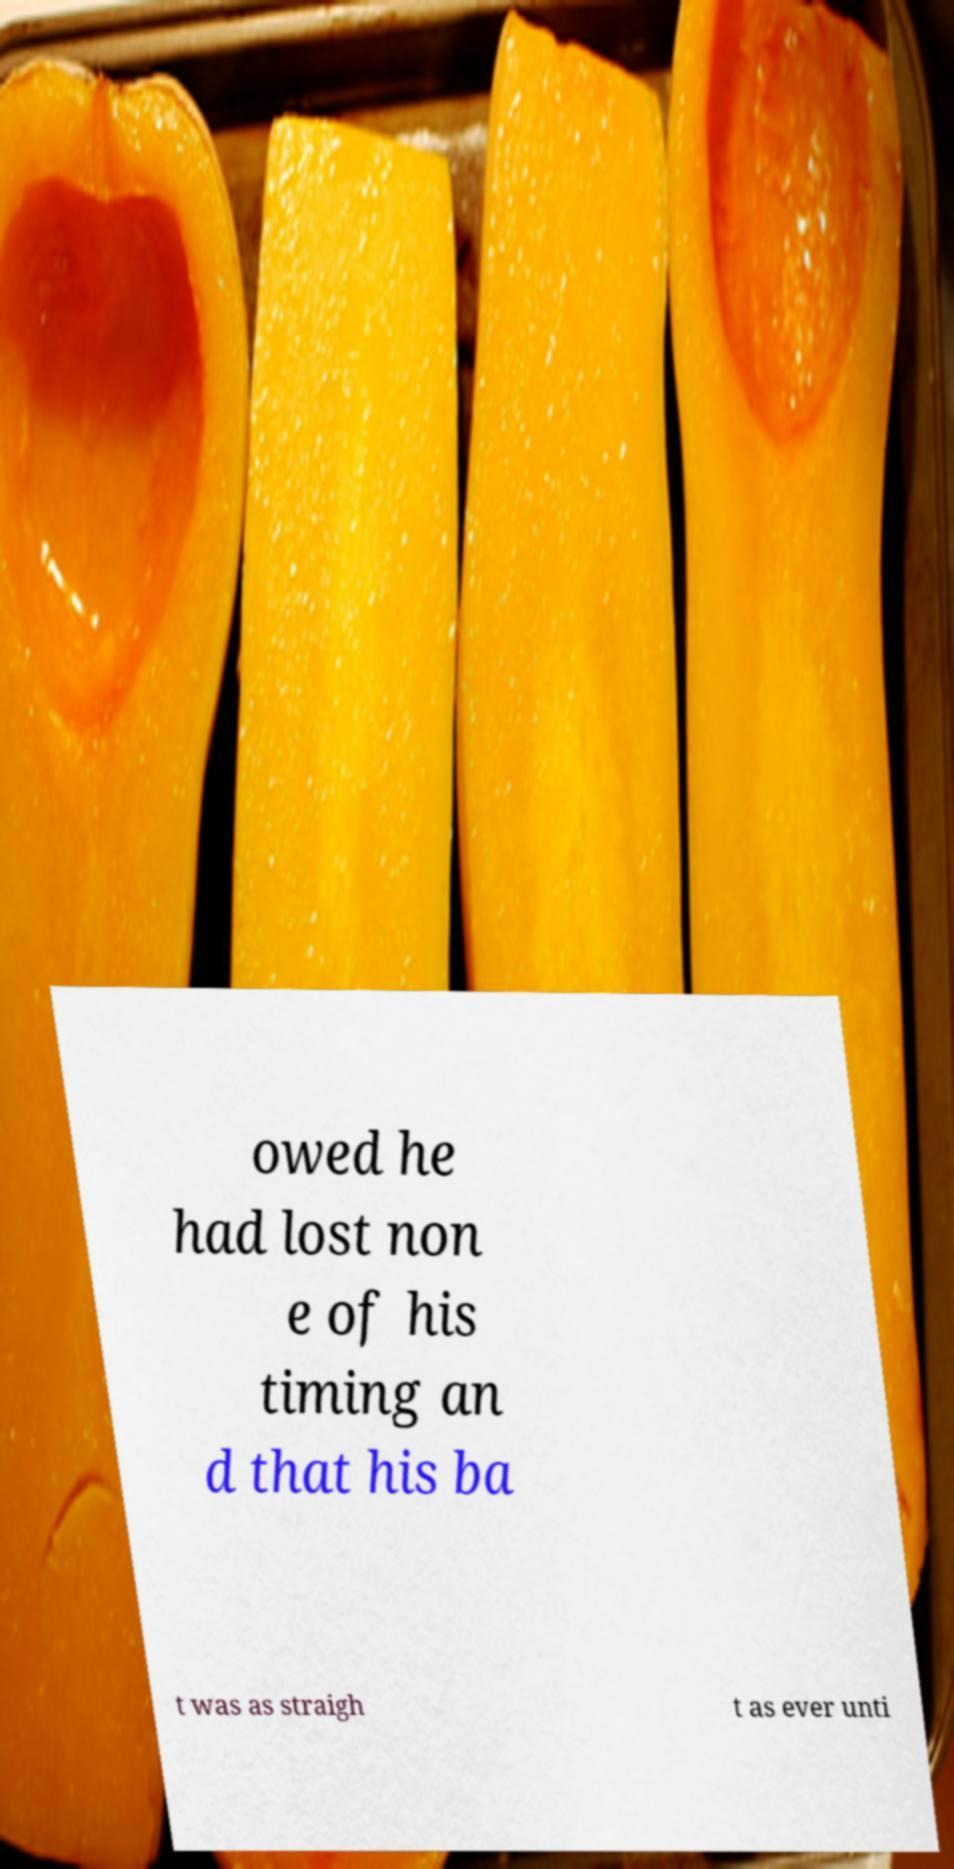For documentation purposes, I need the text within this image transcribed. Could you provide that? owed he had lost non e of his timing an d that his ba t was as straigh t as ever unti 